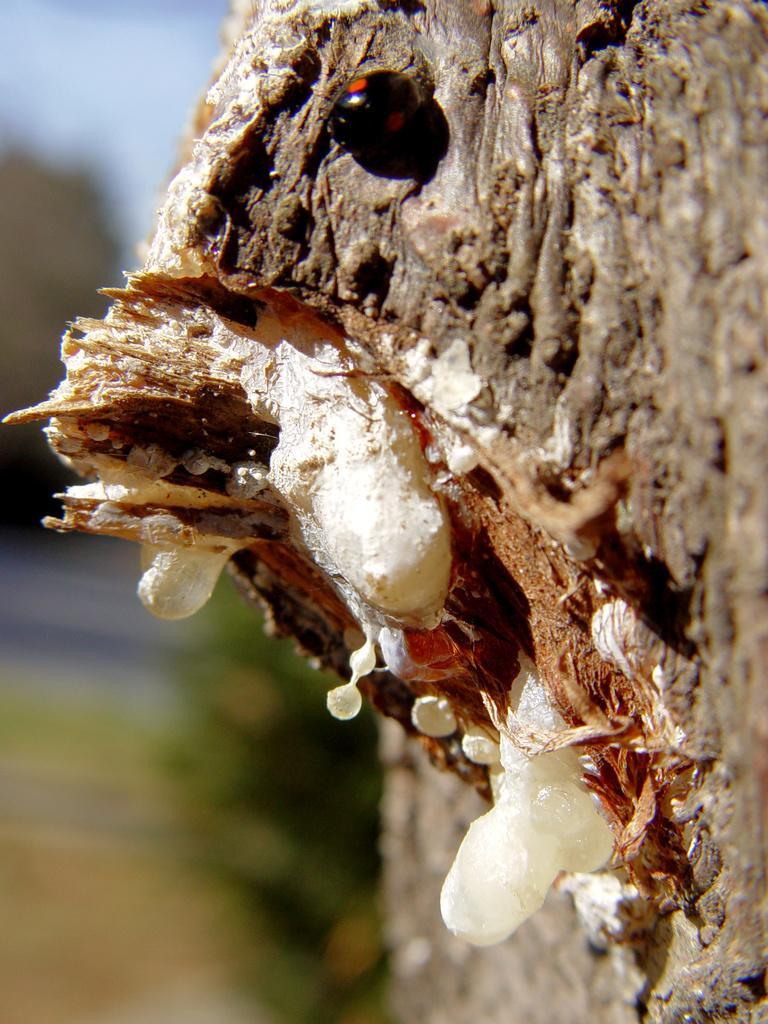Can you describe this image briefly? On the top we can see a bug on the wood. Here we can see a white color tree gum. On the bottom we can see plant. Here it's a road. On the left we can see tree. On the top left corner there is a sky. 